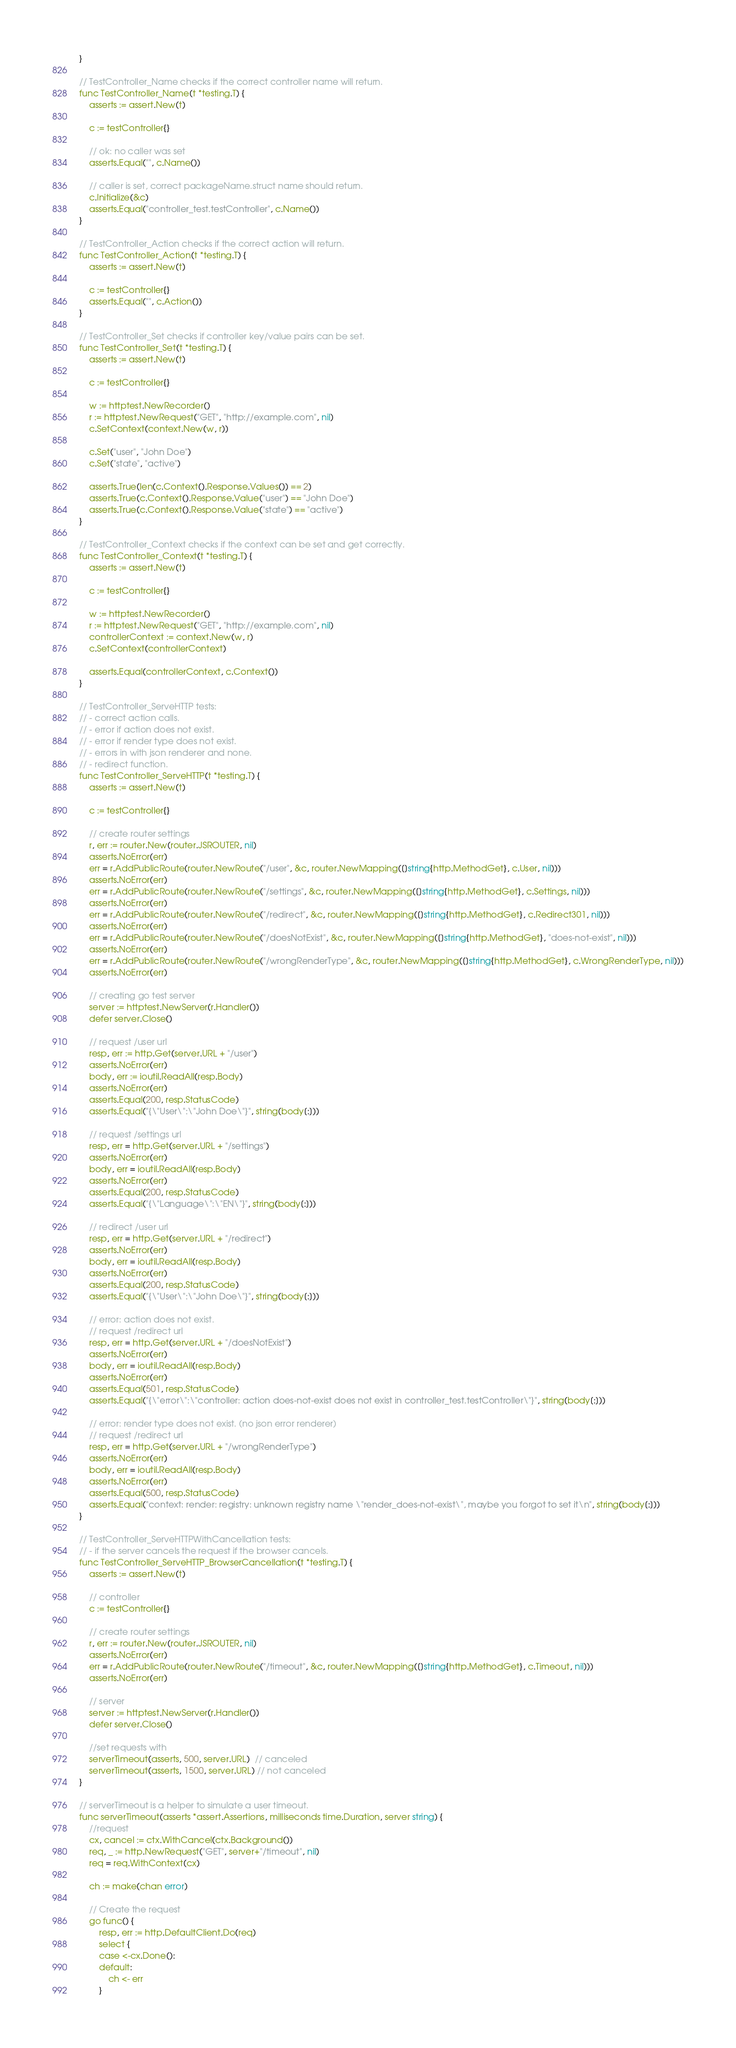<code> <loc_0><loc_0><loc_500><loc_500><_Go_>
}

// TestController_Name checks if the correct controller name will return.
func TestController_Name(t *testing.T) {
	asserts := assert.New(t)

	c := testController{}

	// ok: no caller was set
	asserts.Equal("", c.Name())

	// caller is set, correct packageName.struct name should return.
	c.Initialize(&c)
	asserts.Equal("controller_test.testController", c.Name())
}

// TestController_Action checks if the correct action will return.
func TestController_Action(t *testing.T) {
	asserts := assert.New(t)

	c := testController{}
	asserts.Equal("", c.Action())
}

// TestController_Set checks if controller key/value pairs can be set.
func TestController_Set(t *testing.T) {
	asserts := assert.New(t)

	c := testController{}

	w := httptest.NewRecorder()
	r := httptest.NewRequest("GET", "http://example.com", nil)
	c.SetContext(context.New(w, r))

	c.Set("user", "John Doe")
	c.Set("state", "active")

	asserts.True(len(c.Context().Response.Values()) == 2)
	asserts.True(c.Context().Response.Value("user") == "John Doe")
	asserts.True(c.Context().Response.Value("state") == "active")
}

// TestController_Context checks if the context can be set and get correctly.
func TestController_Context(t *testing.T) {
	asserts := assert.New(t)

	c := testController{}

	w := httptest.NewRecorder()
	r := httptest.NewRequest("GET", "http://example.com", nil)
	controllerContext := context.New(w, r)
	c.SetContext(controllerContext)

	asserts.Equal(controllerContext, c.Context())
}

// TestController_ServeHTTP tests:
// - correct action calls.
// - error if action does not exist.
// - error if render type does not exist.
// - errors in with json renderer and none.
// - redirect function.
func TestController_ServeHTTP(t *testing.T) {
	asserts := assert.New(t)

	c := testController{}

	// create router settings
	r, err := router.New(router.JSROUTER, nil)
	asserts.NoError(err)
	err = r.AddPublicRoute(router.NewRoute("/user", &c, router.NewMapping([]string{http.MethodGet}, c.User, nil)))
	asserts.NoError(err)
	err = r.AddPublicRoute(router.NewRoute("/settings", &c, router.NewMapping([]string{http.MethodGet}, c.Settings, nil)))
	asserts.NoError(err)
	err = r.AddPublicRoute(router.NewRoute("/redirect", &c, router.NewMapping([]string{http.MethodGet}, c.Redirect301, nil)))
	asserts.NoError(err)
	err = r.AddPublicRoute(router.NewRoute("/doesNotExist", &c, router.NewMapping([]string{http.MethodGet}, "does-not-exist", nil)))
	asserts.NoError(err)
	err = r.AddPublicRoute(router.NewRoute("/wrongRenderType", &c, router.NewMapping([]string{http.MethodGet}, c.WrongRenderType, nil)))
	asserts.NoError(err)

	// creating go test server
	server := httptest.NewServer(r.Handler())
	defer server.Close()

	// request /user url
	resp, err := http.Get(server.URL + "/user")
	asserts.NoError(err)
	body, err := ioutil.ReadAll(resp.Body)
	asserts.NoError(err)
	asserts.Equal(200, resp.StatusCode)
	asserts.Equal("{\"User\":\"John Doe\"}", string(body[:]))

	// request /settings url
	resp, err = http.Get(server.URL + "/settings")
	asserts.NoError(err)
	body, err = ioutil.ReadAll(resp.Body)
	asserts.NoError(err)
	asserts.Equal(200, resp.StatusCode)
	asserts.Equal("{\"Language\":\"EN\"}", string(body[:]))

	// redirect /user url
	resp, err = http.Get(server.URL + "/redirect")
	asserts.NoError(err)
	body, err = ioutil.ReadAll(resp.Body)
	asserts.NoError(err)
	asserts.Equal(200, resp.StatusCode)
	asserts.Equal("{\"User\":\"John Doe\"}", string(body[:]))

	// error: action does not exist.
	// request /redirect url
	resp, err = http.Get(server.URL + "/doesNotExist")
	asserts.NoError(err)
	body, err = ioutil.ReadAll(resp.Body)
	asserts.NoError(err)
	asserts.Equal(501, resp.StatusCode)
	asserts.Equal("{\"error\":\"controller: action does-not-exist does not exist in controller_test.testController\"}", string(body[:]))

	// error: render type does not exist. (no json error renderer)
	// request /redirect url
	resp, err = http.Get(server.URL + "/wrongRenderType")
	asserts.NoError(err)
	body, err = ioutil.ReadAll(resp.Body)
	asserts.NoError(err)
	asserts.Equal(500, resp.StatusCode)
	asserts.Equal("context: render: registry: unknown registry name \"render_does-not-exist\", maybe you forgot to set it\n", string(body[:]))
}

// TestController_ServeHTTPWithCancellation tests:
// - if the server cancels the request if the browser cancels.
func TestController_ServeHTTP_BrowserCancellation(t *testing.T) {
	asserts := assert.New(t)

	// controller
	c := testController{}

	// create router settings
	r, err := router.New(router.JSROUTER, nil)
	asserts.NoError(err)
	err = r.AddPublicRoute(router.NewRoute("/timeout", &c, router.NewMapping([]string{http.MethodGet}, c.Timeout, nil)))
	asserts.NoError(err)

	// server
	server := httptest.NewServer(r.Handler())
	defer server.Close()

	//set requests with
	serverTimeout(asserts, 500, server.URL)  // canceled
	serverTimeout(asserts, 1500, server.URL) // not canceled
}

// serverTimeout is a helper to simulate a user timeout.
func serverTimeout(asserts *assert.Assertions, milliseconds time.Duration, server string) {
	//request
	cx, cancel := ctx.WithCancel(ctx.Background())
	req, _ := http.NewRequest("GET", server+"/timeout", nil)
	req = req.WithContext(cx)

	ch := make(chan error)

	// Create the request
	go func() {
		resp, err := http.DefaultClient.Do(req)
		select {
		case <-cx.Done():
		default:
			ch <- err
		}</code> 